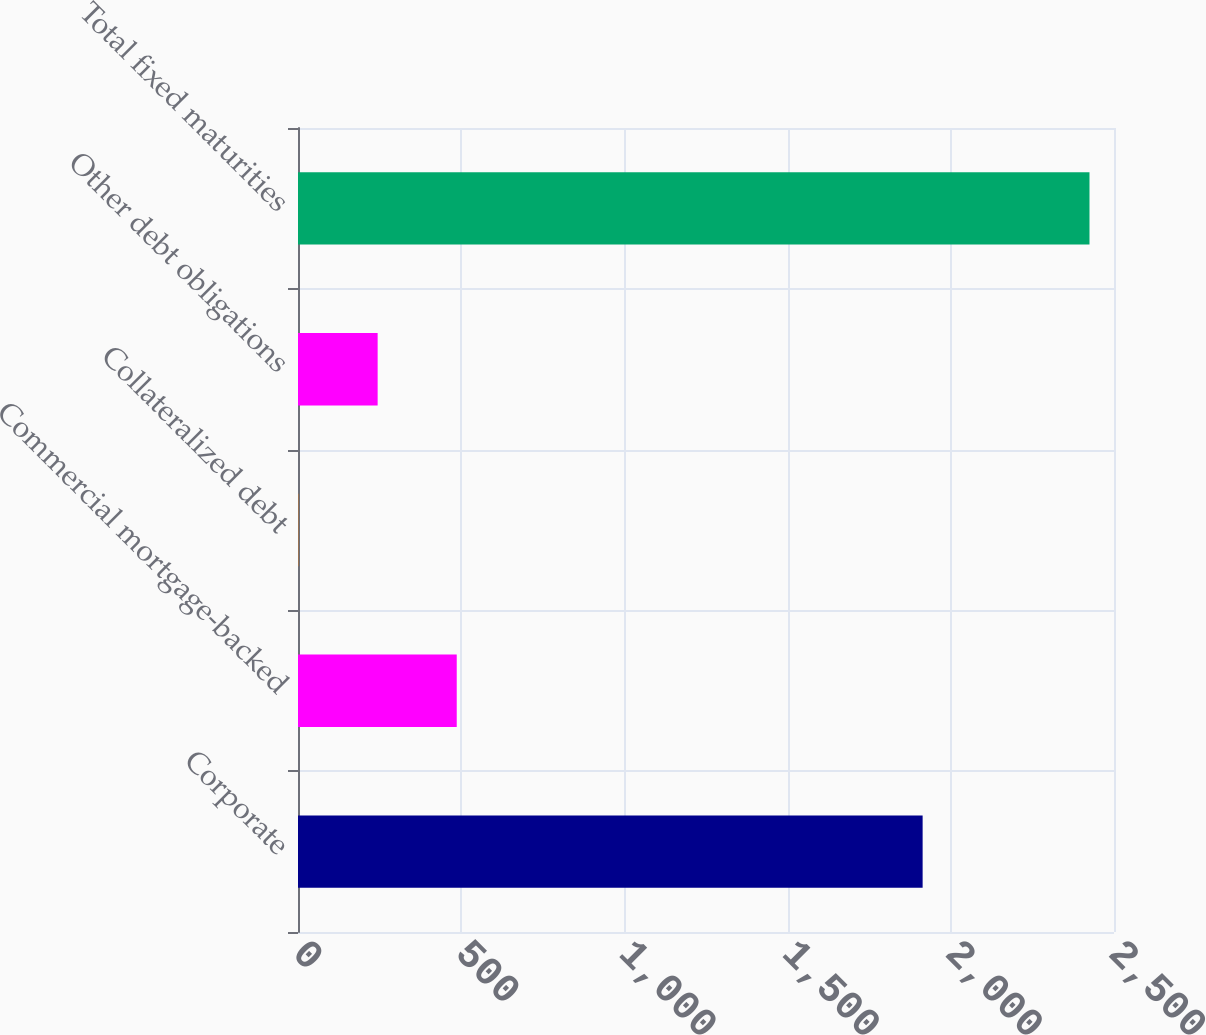Convert chart. <chart><loc_0><loc_0><loc_500><loc_500><bar_chart><fcel>Corporate<fcel>Commercial mortgage-backed<fcel>Collateralized debt<fcel>Other debt obligations<fcel>Total fixed maturities<nl><fcel>1913.7<fcel>486.34<fcel>1.7<fcel>244.02<fcel>2424.9<nl></chart> 